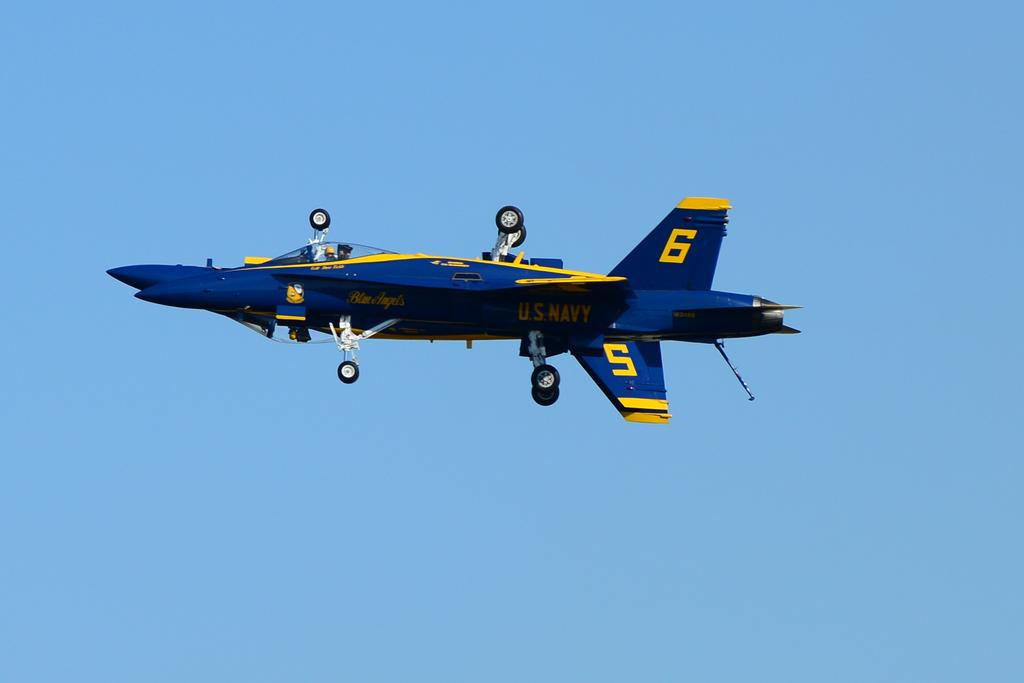Provide a one-sentence caption for the provided image. A blue and yellow aircraft in mid-flight is labeled with the numbers 5 and 6. 